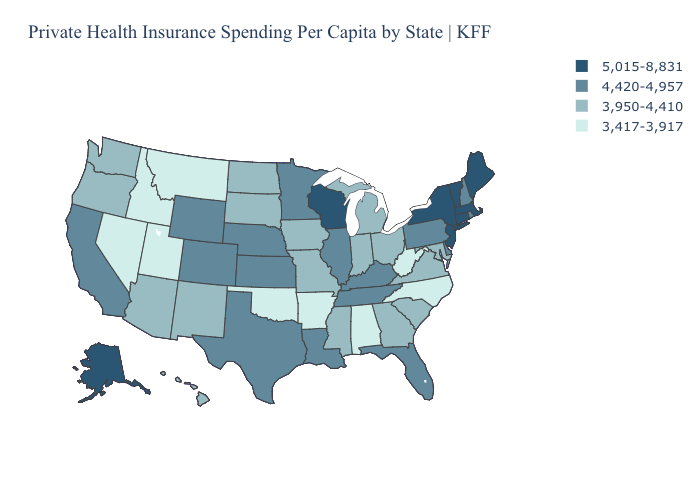Among the states that border Indiana , does Ohio have the highest value?
Keep it brief. No. Does Alaska have the lowest value in the West?
Write a very short answer. No. What is the value of Florida?
Answer briefly. 4,420-4,957. What is the value of Oklahoma?
Short answer required. 3,417-3,917. Which states hav the highest value in the South?
Quick response, please. Delaware, Florida, Kentucky, Louisiana, Tennessee, Texas. What is the highest value in the USA?
Write a very short answer. 5,015-8,831. Which states have the lowest value in the MidWest?
Give a very brief answer. Indiana, Iowa, Michigan, Missouri, North Dakota, Ohio, South Dakota. Does Kansas have a higher value than West Virginia?
Answer briefly. Yes. Name the states that have a value in the range 5,015-8,831?
Answer briefly. Alaska, Connecticut, Maine, Massachusetts, New Jersey, New York, Vermont, Wisconsin. Name the states that have a value in the range 4,420-4,957?
Quick response, please. California, Colorado, Delaware, Florida, Illinois, Kansas, Kentucky, Louisiana, Minnesota, Nebraska, New Hampshire, Pennsylvania, Rhode Island, Tennessee, Texas, Wyoming. What is the highest value in the USA?
Answer briefly. 5,015-8,831. What is the value of North Dakota?
Be succinct. 3,950-4,410. Does Utah have the lowest value in the West?
Quick response, please. Yes. Name the states that have a value in the range 4,420-4,957?
Write a very short answer. California, Colorado, Delaware, Florida, Illinois, Kansas, Kentucky, Louisiana, Minnesota, Nebraska, New Hampshire, Pennsylvania, Rhode Island, Tennessee, Texas, Wyoming. What is the lowest value in states that border Texas?
Give a very brief answer. 3,417-3,917. 